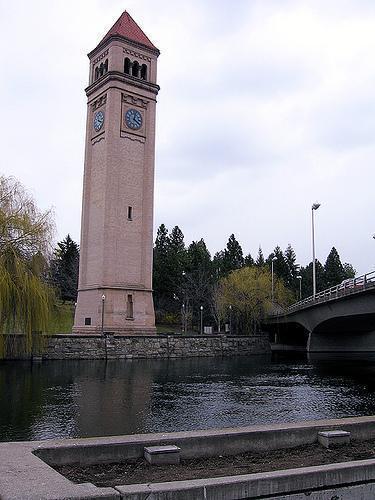What is the clock attached to?
From the following set of four choices, select the accurate answer to respond to the question.
Options: Tower, bar stool, kitchen wall, arena screen. Tower. 